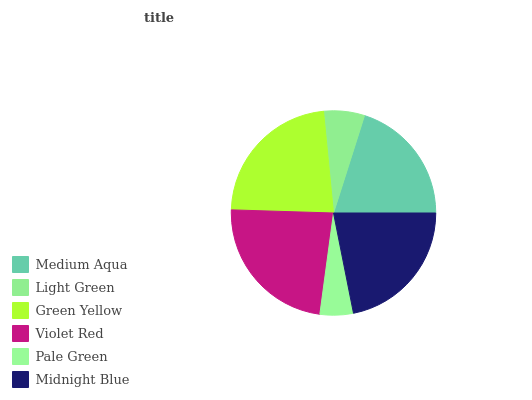Is Pale Green the minimum?
Answer yes or no. Yes. Is Violet Red the maximum?
Answer yes or no. Yes. Is Light Green the minimum?
Answer yes or no. No. Is Light Green the maximum?
Answer yes or no. No. Is Medium Aqua greater than Light Green?
Answer yes or no. Yes. Is Light Green less than Medium Aqua?
Answer yes or no. Yes. Is Light Green greater than Medium Aqua?
Answer yes or no. No. Is Medium Aqua less than Light Green?
Answer yes or no. No. Is Midnight Blue the high median?
Answer yes or no. Yes. Is Medium Aqua the low median?
Answer yes or no. Yes. Is Green Yellow the high median?
Answer yes or no. No. Is Light Green the low median?
Answer yes or no. No. 